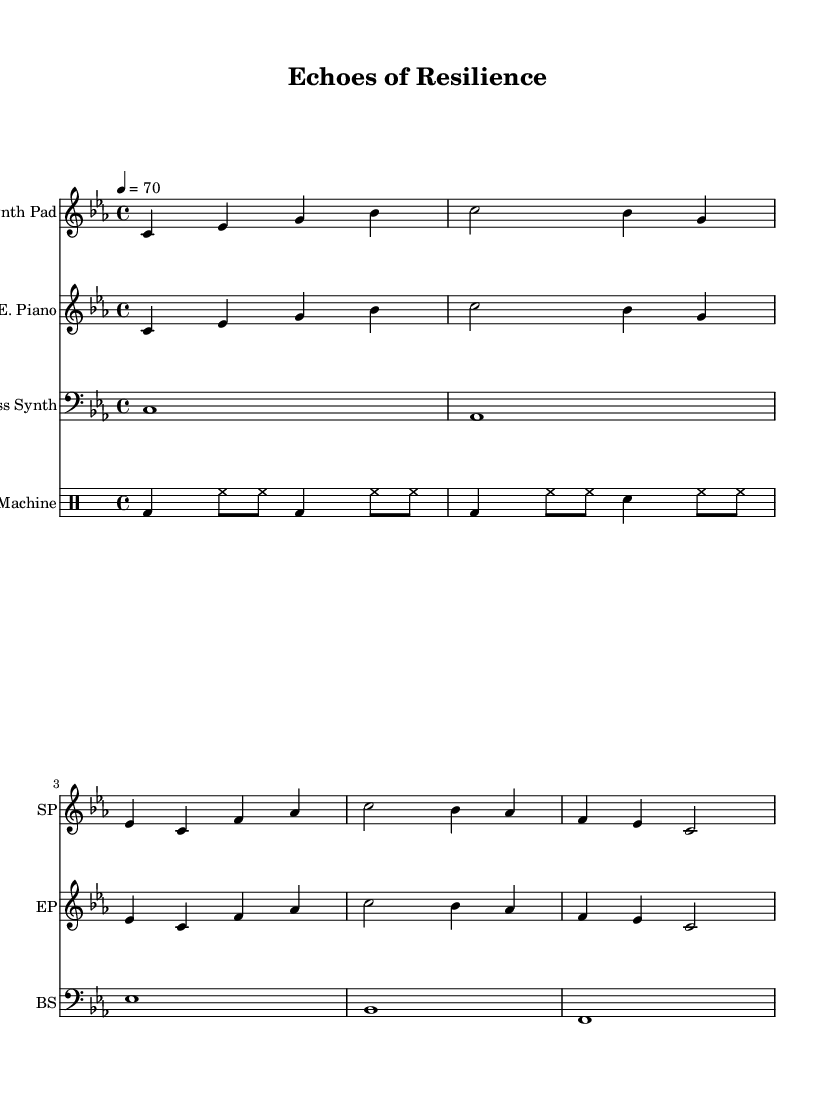What is the key signature of this music? The key signature is C minor, which has three flats. This can be identified by looking at the key signature indicated at the beginning of the staff.
Answer: C minor What is the time signature of this composition? The time signature is 4/4, commonly found at the beginning of the sheet music, which indicates that there are four beats in each measure.
Answer: 4/4 What is the tempo marking for this piece? The tempo marking is a quarter note equals 70 beats per minute. This tempo is specified at the beginning of the score, showing how fast the piece should be played.
Answer: 70 How many different instruments are featured in the composition? There are four different instruments: Synth Pad, Electric Piano, Bass Synth, and Drum Machine. This can be derived from the labels at the beginning of each staff in the score, indicating each instrument.
Answer: Four What pitch does the Bass Synth start on? The Bass Synth starts on C, as indicated by the first note in the Bass Synth staff, which is the lowest note in this part.
Answer: C How many measures are in the Synth Pad and Electric Piano parts? Both the Synth Pad and Electric Piano parts each have four measures. This can be determined by counting the number of separated groups of notes in each respective staff.
Answer: Four What type of rhythmic pattern is used in the drum section? The drum pattern consists of a bass drum and hi-hat rhythm, which is characterized by a steady beat with variations in the hi-hat. This is identifiable in the drum staff written in drum notation.
Answer: Bass and hi-hat 